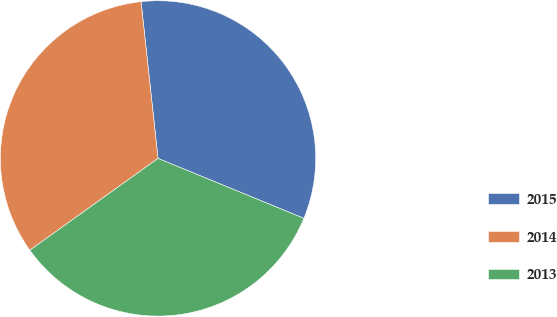<chart> <loc_0><loc_0><loc_500><loc_500><pie_chart><fcel>2015<fcel>2014<fcel>2013<nl><fcel>32.92%<fcel>33.18%<fcel>33.9%<nl></chart> 